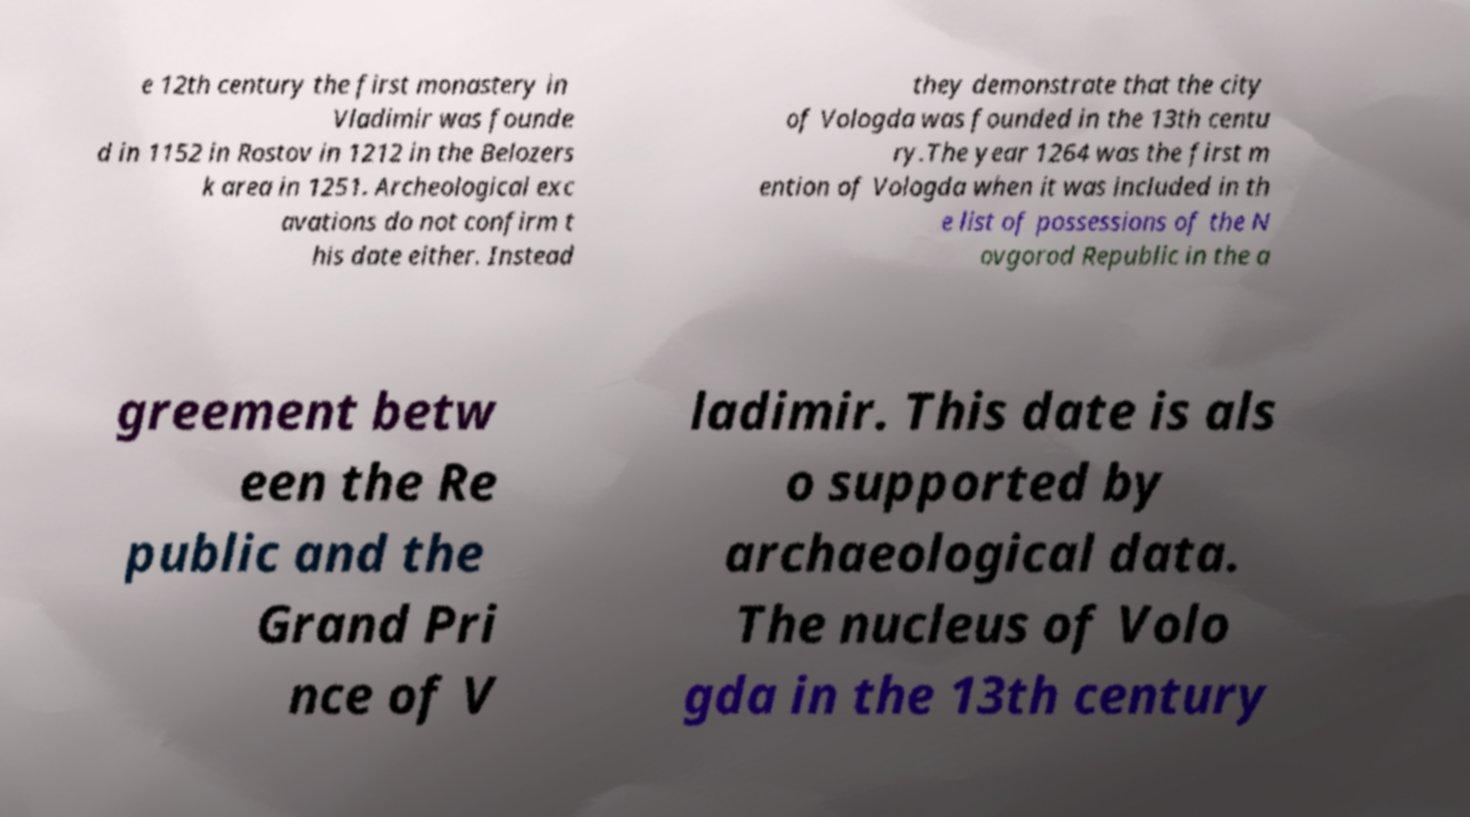There's text embedded in this image that I need extracted. Can you transcribe it verbatim? e 12th century the first monastery in Vladimir was founde d in 1152 in Rostov in 1212 in the Belozers k area in 1251. Archeological exc avations do not confirm t his date either. Instead they demonstrate that the city of Vologda was founded in the 13th centu ry.The year 1264 was the first m ention of Vologda when it was included in th e list of possessions of the N ovgorod Republic in the a greement betw een the Re public and the Grand Pri nce of V ladimir. This date is als o supported by archaeological data. The nucleus of Volo gda in the 13th century 